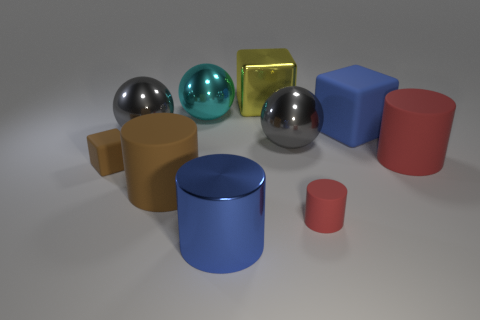Is the cyan ball made of the same material as the small red cylinder?
Offer a terse response. No. How many big objects are behind the tiny brown matte block and in front of the large blue matte thing?
Ensure brevity in your answer.  3. How many other things are there of the same color as the shiny block?
Offer a very short reply. 0. What number of brown objects are shiny objects or big metal spheres?
Your answer should be compact. 0. What is the size of the brown cylinder?
Make the answer very short. Large. How many matte things are either gray blocks or cyan spheres?
Offer a very short reply. 0. Are there fewer tiny shiny cylinders than large objects?
Provide a short and direct response. Yes. How many other things are made of the same material as the large yellow thing?
Ensure brevity in your answer.  4. What is the size of the brown thing that is the same shape as the blue metal thing?
Provide a succinct answer. Large. Do the big blue object that is in front of the brown matte cube and the large blue object that is behind the big blue metal cylinder have the same material?
Make the answer very short. No. 